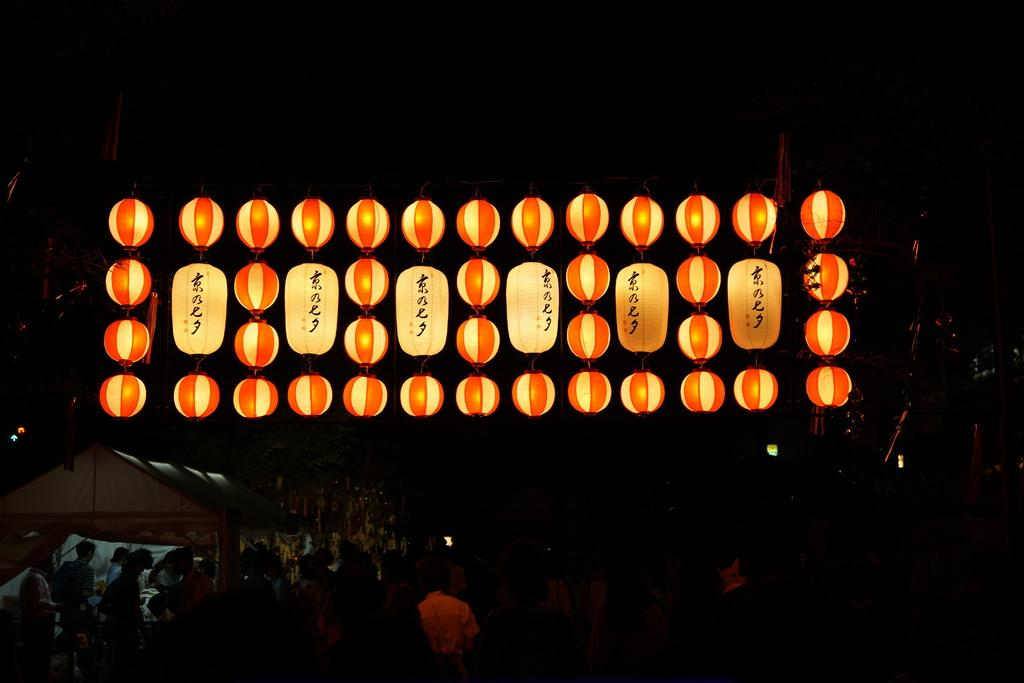What objects are present in the image that provide light? There are lanterns in the image that provide light. What else can be seen in the image besides the lanterns? There are people standing in the image. What structure is located on the left side of the image? There appears to be a house on the left side of the image. How would you describe the overall lighting in the image? The background of the image is dark. What type of riddle is being solved by the people in the image? There is no indication in the image that the people are solving a riddle. How much does the bucket weigh in the image? There is no bucket present in the image, so its weight cannot be determined. 